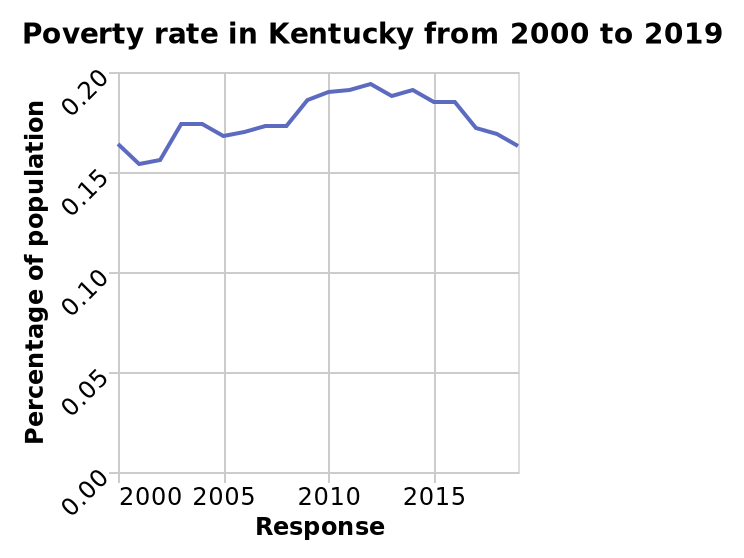<image>
What does the y-axis show?  The y-axis shows the "Percentage of population." Describe the following image in detail This line chart is called Poverty rate in Kentucky from 2000 to 2019. The x-axis measures Response while the y-axis shows Percentage of population. In which state is the poverty rate represented in the line chart?  The poverty rate is represented in Kentucky. 